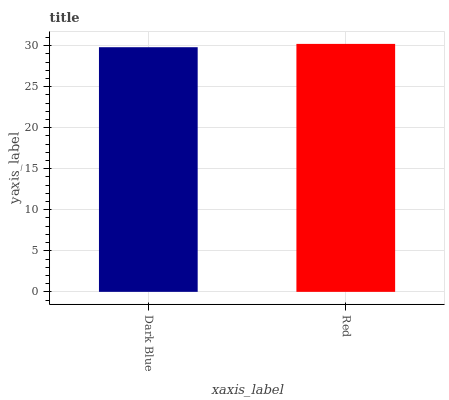Is Dark Blue the minimum?
Answer yes or no. Yes. Is Red the maximum?
Answer yes or no. Yes. Is Red the minimum?
Answer yes or no. No. Is Red greater than Dark Blue?
Answer yes or no. Yes. Is Dark Blue less than Red?
Answer yes or no. Yes. Is Dark Blue greater than Red?
Answer yes or no. No. Is Red less than Dark Blue?
Answer yes or no. No. Is Red the high median?
Answer yes or no. Yes. Is Dark Blue the low median?
Answer yes or no. Yes. Is Dark Blue the high median?
Answer yes or no. No. Is Red the low median?
Answer yes or no. No. 